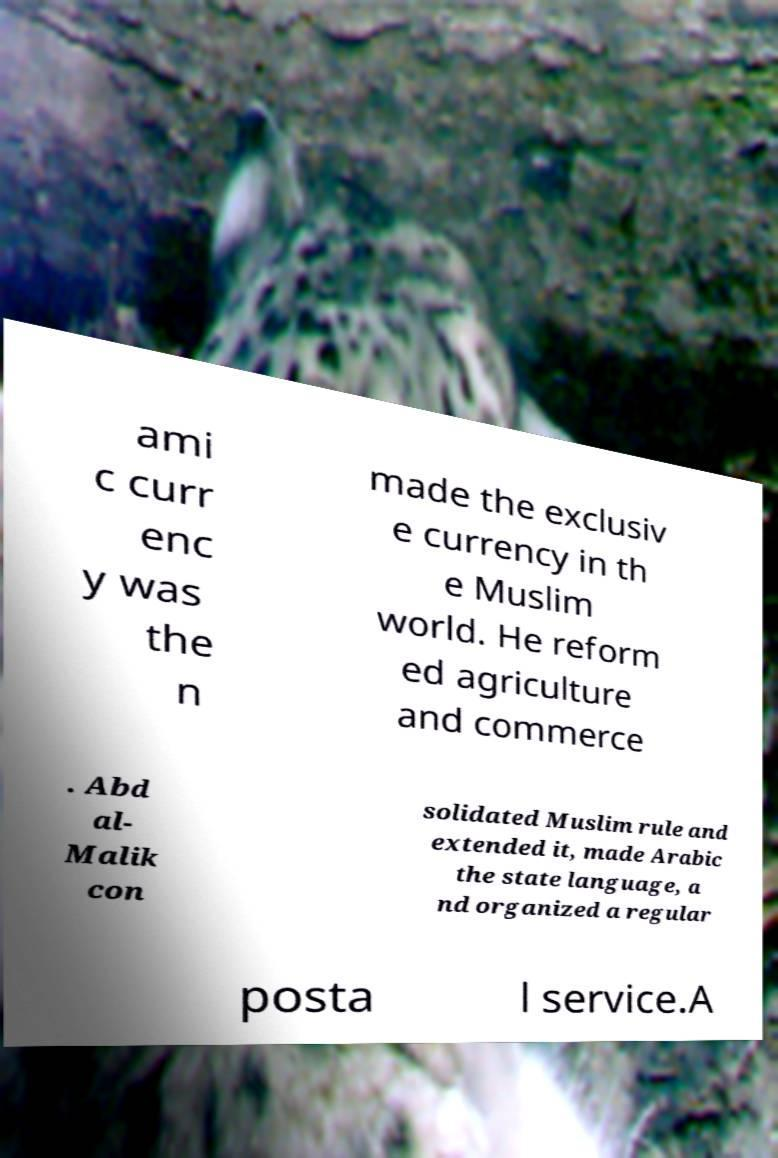Can you accurately transcribe the text from the provided image for me? ami c curr enc y was the n made the exclusiv e currency in th e Muslim world. He reform ed agriculture and commerce . Abd al- Malik con solidated Muslim rule and extended it, made Arabic the state language, a nd organized a regular posta l service.A 